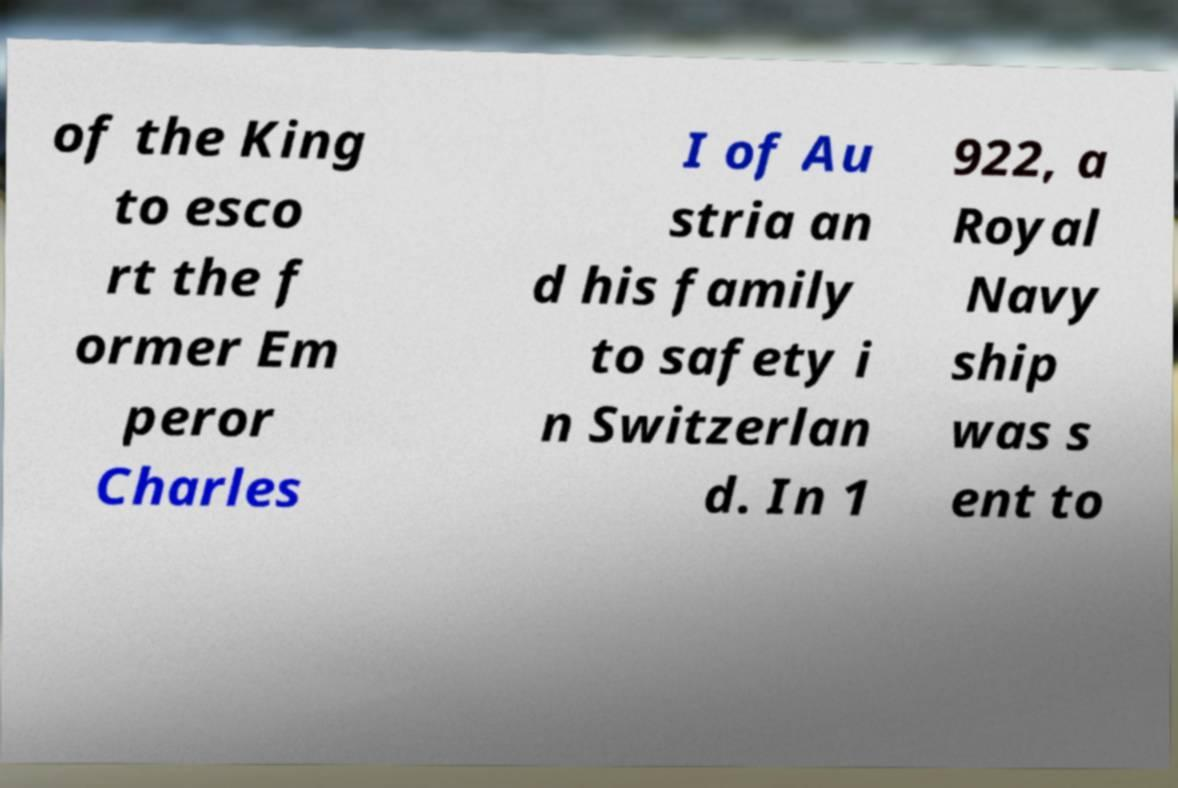There's text embedded in this image that I need extracted. Can you transcribe it verbatim? of the King to esco rt the f ormer Em peror Charles I of Au stria an d his family to safety i n Switzerlan d. In 1 922, a Royal Navy ship was s ent to 